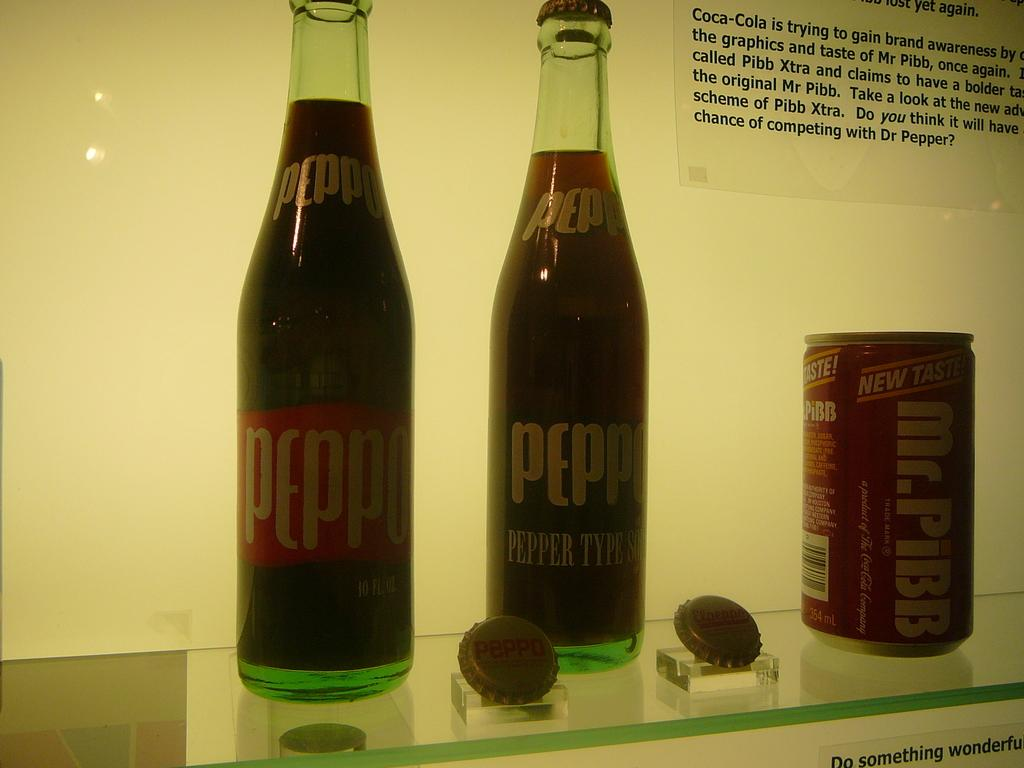<image>
Summarize the visual content of the image. Two glass soft drink bottles and a Mr. Pibb pop can. 